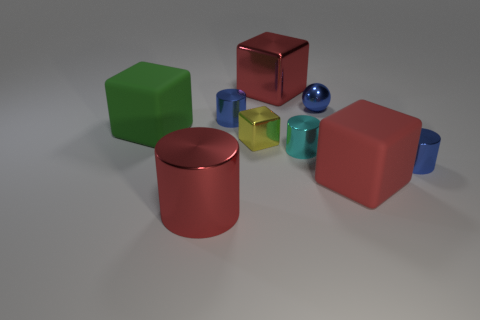What's the texture of the surfaces of the objects? The objects exhibit a variety of textures: the green, red, and blue blocks have a smooth, untextured surface, whereas the transparent cubes and spheres have a slightly reflective texture that mimics glass or polished crystal. 